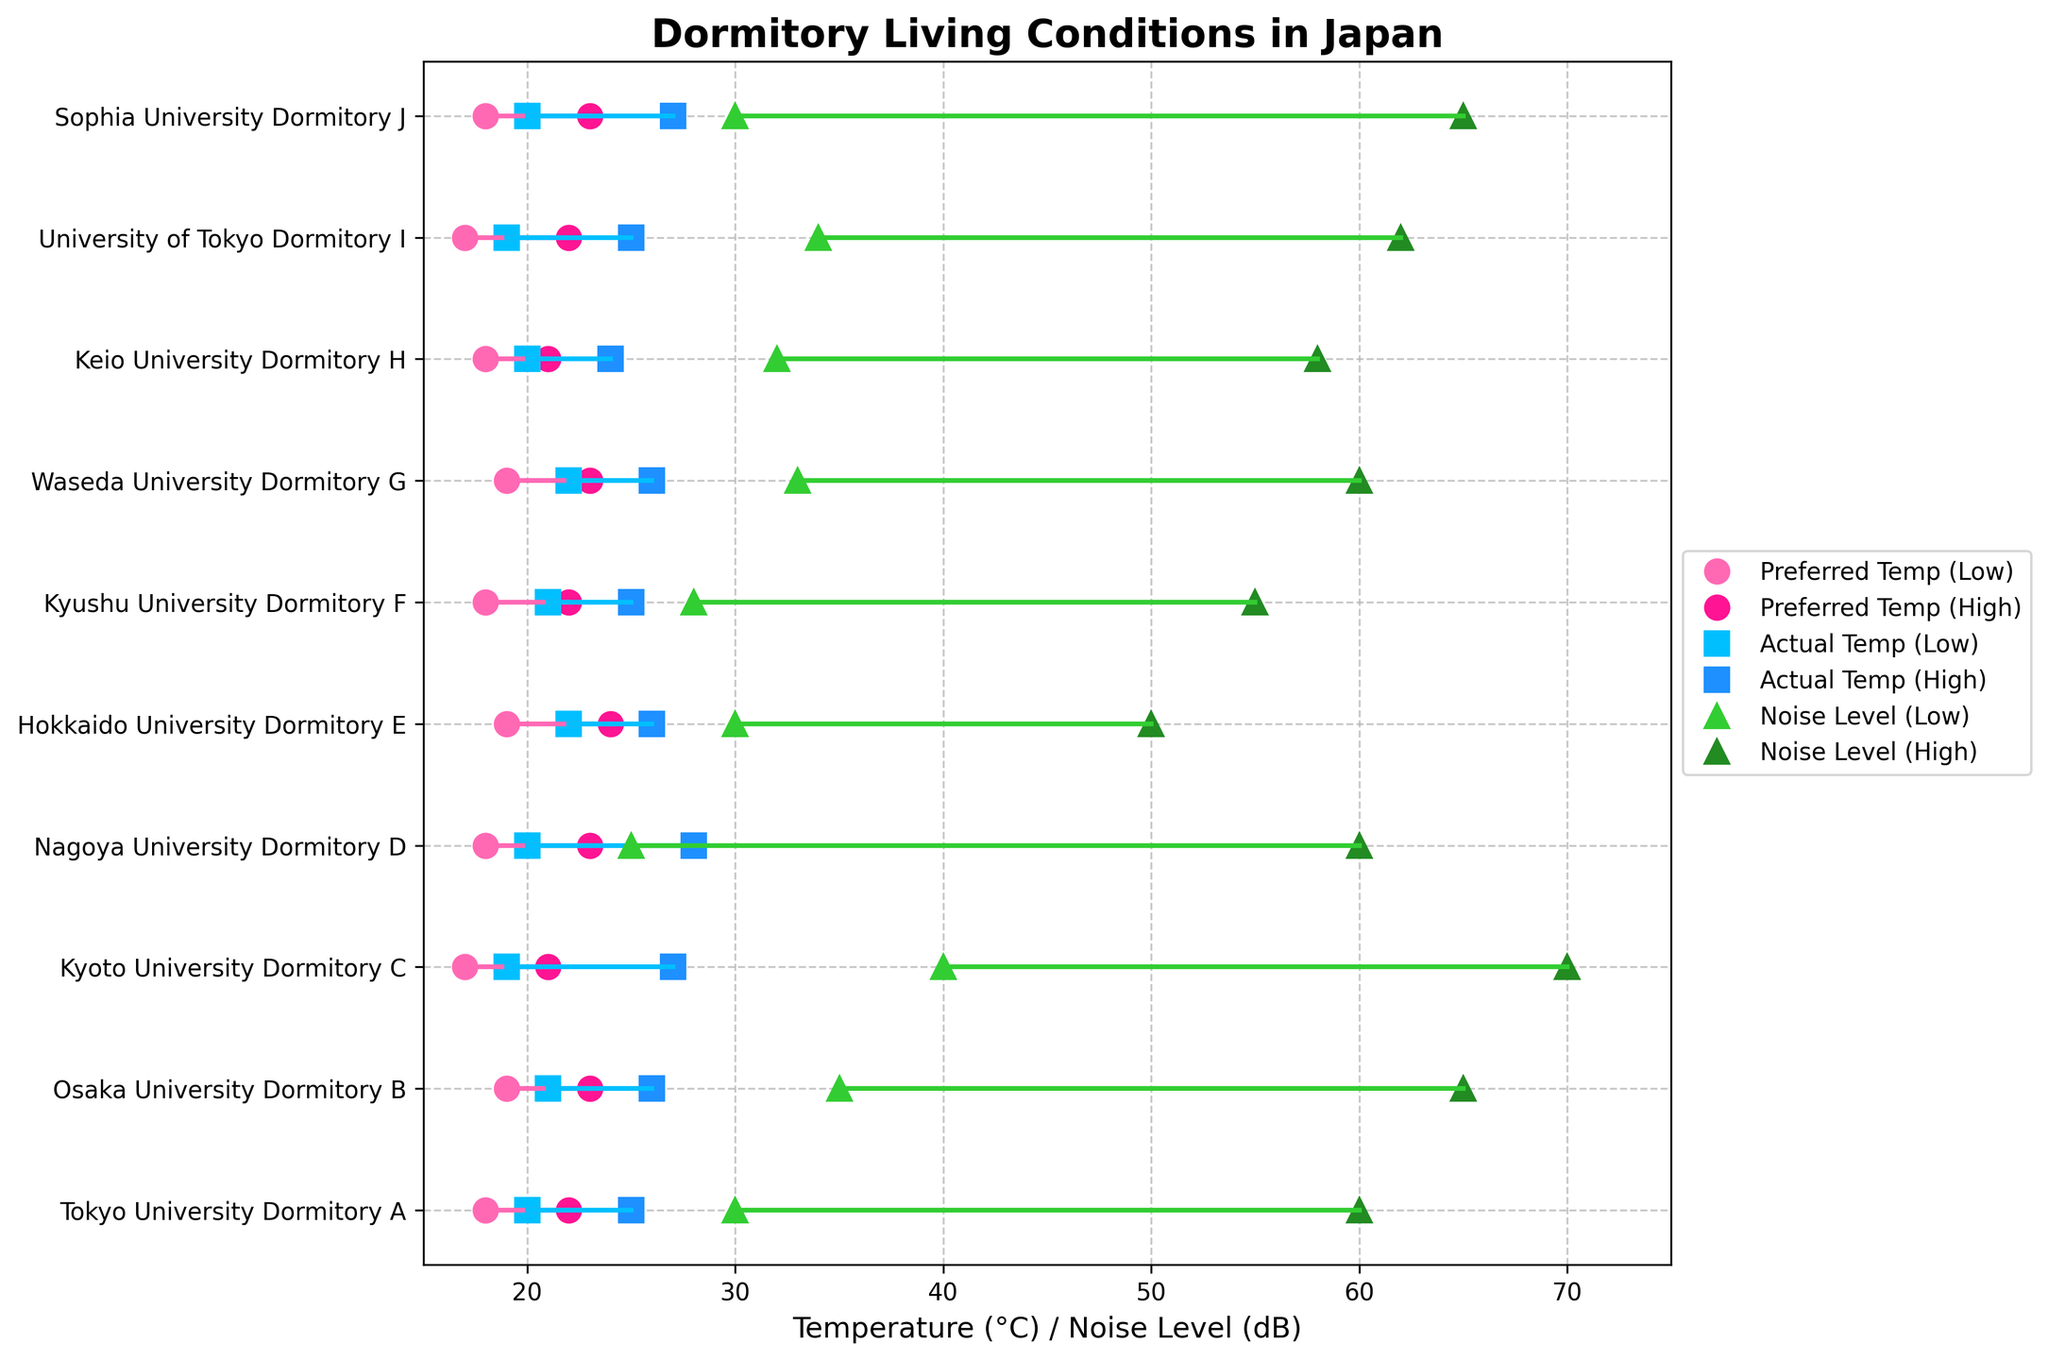What is the title of the figure? The title of the figure is located at the top, often in bold, and provides a summary of what the figure is about.
Answer: Dormitory Living Conditions in Japan Which dormitory has the highest actual temperature high? To find the highest actual temperature high, look for the highest position of the blue squares (representing Actual Temp (High)) on the x-axis.
Answer: Nagoya University Dormitory D How many dormitories prefer the low temperature to be 18°C? Count the number of pink circles (representing Preferred Temp (Low)) at the 18°C on the x-axis.
Answer: Four What is the range of noise levels for Kyoto University Dormitory C? The range of noise levels can be found by subtracting the lower noise level from the higher noise level for Kyoto University Dormitory C.
Answer: 30 dB (70 - 40) Which dormitory has the smallest difference between preferred and actual temperatures for both low and high values? Calculate the differences between Preferred Temp (Low) and Actual Temp (Low), as well as Preferred Temp (High) and Actual Temp (High) for each dormitory, then find the one with the smallest sum of these differences.
Answer: Keio University Dormitory H What is the average actual temperature high across all the dormitories? Add up all the actual temperature highs and divide by the number of dormitories (25 + 26 + 27 + 28 + 26 + 25 + 26 + 24 + 25 + 27). The calculation is (25 + 26 + 27 + 28 + 26 + 25 + 26 + 24 + 25 + 27) / 10.
Answer: 25.9°C Which dormitory has the quietest noise level high? To find the quietest noise level high, look for the lowest position of the dark green triangles (representing Noise Level (High)) on the x-axis.
Answer: Hokkaido University Dormitory E What is the preferred temperature range for Tokyo University Dormitory A? The preferred temperature range is the difference between the preferred high and low temperatures for Tokyo University Dormitory A. It is found by subtracting the preferred low temperature from the preferred high temperature.
Answer: 4°C (22 - 18) Compare the actual and preferred temperatures for Osaka University Dormitory B. Are they closer for the low values or the high values? Subtract the preferred low temperature from the actual low temperature and the preferred high temperature from the actual high temperature, and compare the differences.
Answer: Closer for the high values (2 vs 3) Which dormitory has both low preferred and actual temperatures values below 20°C? Find the dormitory where both the pink circles (Preferred Temp (Low)) and blue squares (Actual Temp (Low)) are below 20°C. There are two such dormitories, compare their low temperature values.
Answer: Kyoto University Dormitory C 